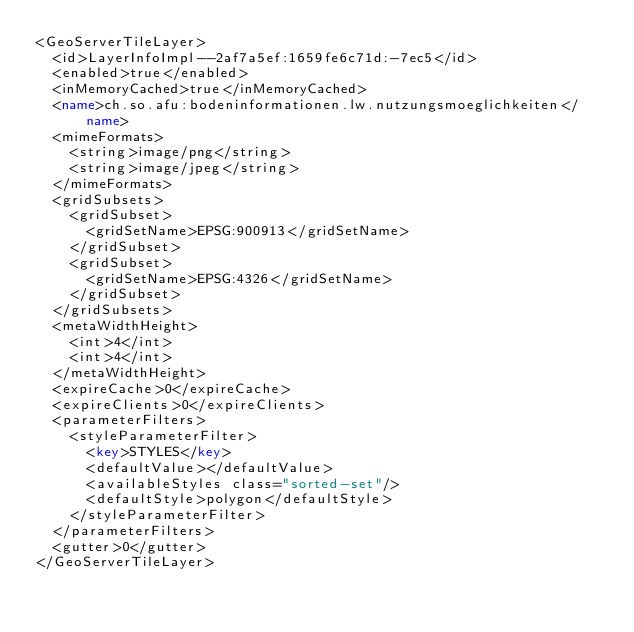Convert code to text. <code><loc_0><loc_0><loc_500><loc_500><_XML_><GeoServerTileLayer>
  <id>LayerInfoImpl--2af7a5ef:1659fe6c71d:-7ec5</id>
  <enabled>true</enabled>
  <inMemoryCached>true</inMemoryCached>
  <name>ch.so.afu:bodeninformationen.lw.nutzungsmoeglichkeiten</name>
  <mimeFormats>
    <string>image/png</string>
    <string>image/jpeg</string>
  </mimeFormats>
  <gridSubsets>
    <gridSubset>
      <gridSetName>EPSG:900913</gridSetName>
    </gridSubset>
    <gridSubset>
      <gridSetName>EPSG:4326</gridSetName>
    </gridSubset>
  </gridSubsets>
  <metaWidthHeight>
    <int>4</int>
    <int>4</int>
  </metaWidthHeight>
  <expireCache>0</expireCache>
  <expireClients>0</expireClients>
  <parameterFilters>
    <styleParameterFilter>
      <key>STYLES</key>
      <defaultValue></defaultValue>
      <availableStyles class="sorted-set"/>
      <defaultStyle>polygon</defaultStyle>
    </styleParameterFilter>
  </parameterFilters>
  <gutter>0</gutter>
</GeoServerTileLayer></code> 